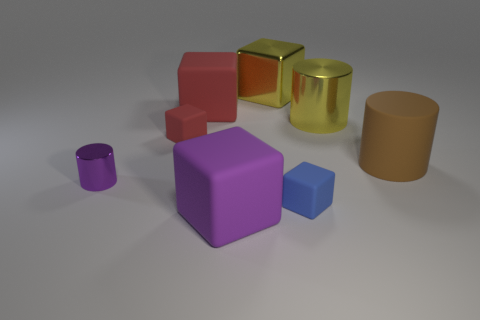There is a yellow cylinder that is the same size as the brown rubber cylinder; what material is it?
Your answer should be compact. Metal. Are there any gray blocks made of the same material as the large red cube?
Your answer should be very brief. No. Does the large brown object have the same shape as the purple thing in front of the tiny purple metal thing?
Keep it short and to the point. No. How many tiny cubes are both in front of the large brown cylinder and behind the big brown matte cylinder?
Make the answer very short. 0. Is the material of the small purple cylinder the same as the big yellow object right of the large yellow block?
Make the answer very short. Yes. Are there an equal number of metallic cylinders in front of the tiny blue rubber object and blue things?
Keep it short and to the point. No. What color is the large shiny object to the right of the shiny cube?
Your response must be concise. Yellow. What number of other things are there of the same color as the big rubber cylinder?
Give a very brief answer. 0. There is a metal cylinder behind the brown matte thing; is it the same size as the purple block?
Give a very brief answer. Yes. There is a yellow cylinder that is behind the tiny purple object; what material is it?
Make the answer very short. Metal. 